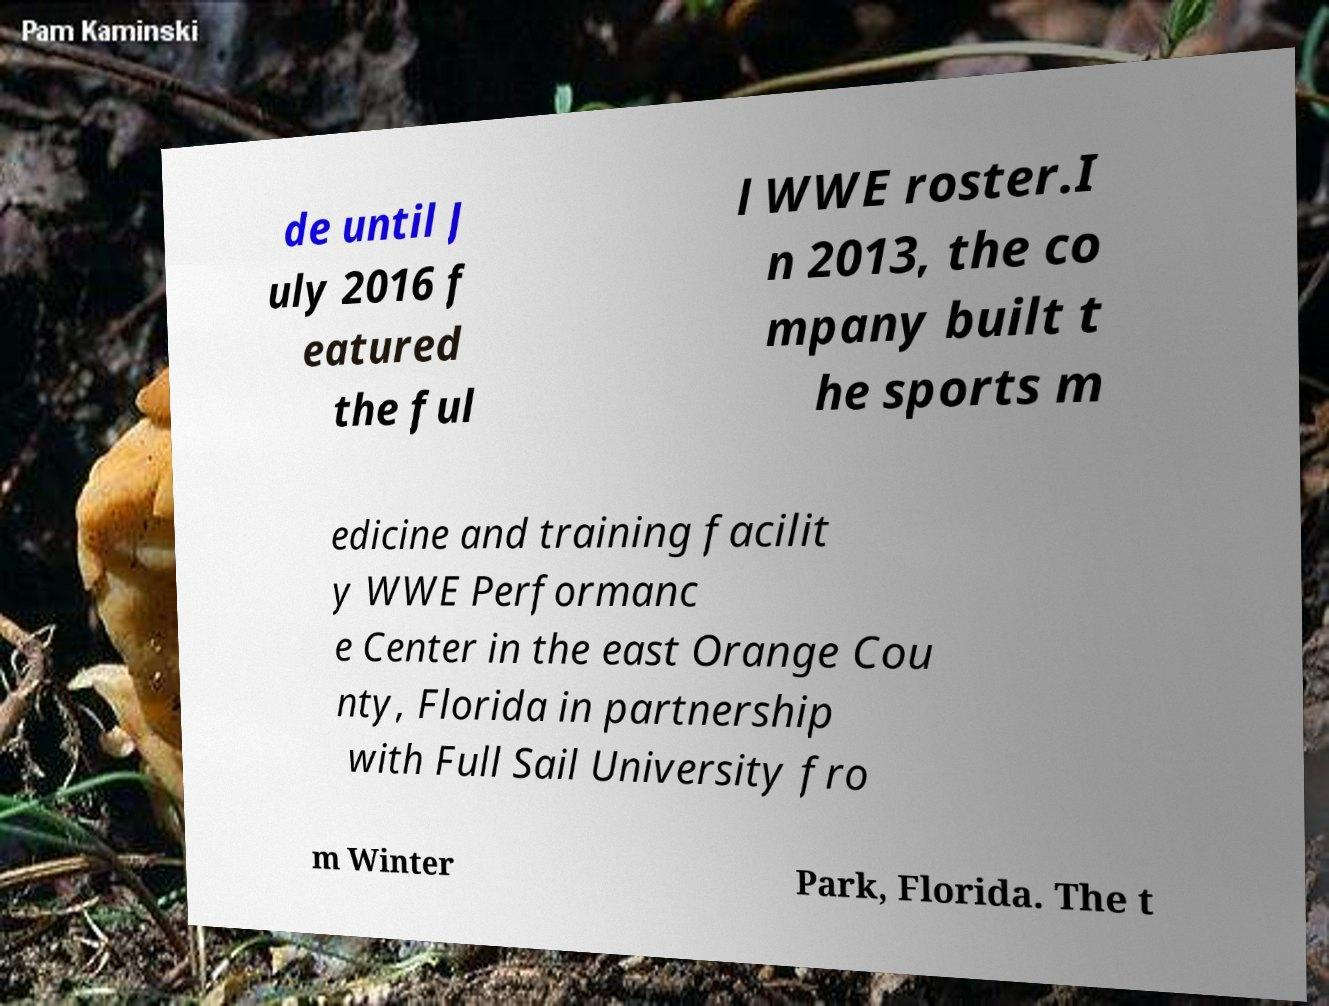Could you extract and type out the text from this image? de until J uly 2016 f eatured the ful l WWE roster.I n 2013, the co mpany built t he sports m edicine and training facilit y WWE Performanc e Center in the east Orange Cou nty, Florida in partnership with Full Sail University fro m Winter Park, Florida. The t 